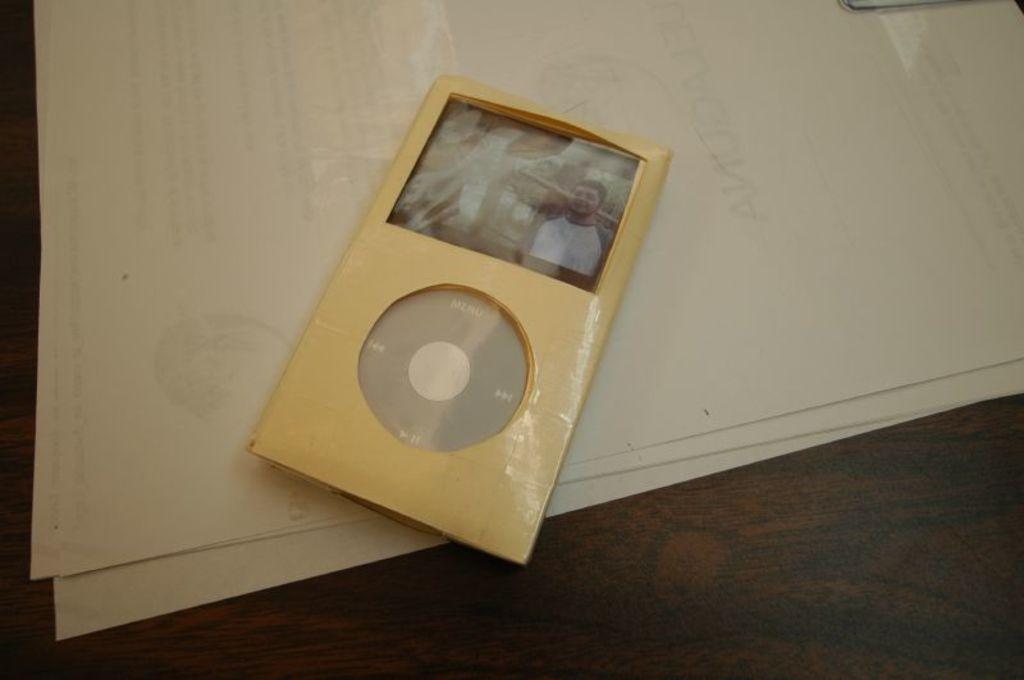How would you summarize this image in a sentence or two? In the image there is an ipod along with some papers on a table. 